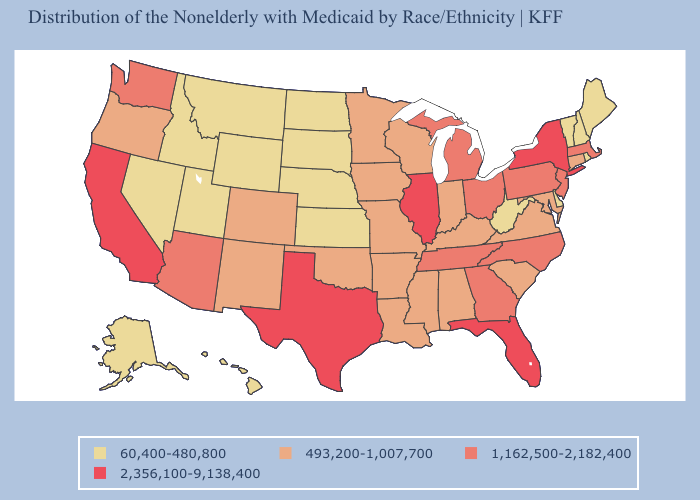Does South Dakota have the highest value in the USA?
Short answer required. No. Does Maine have the highest value in the USA?
Keep it brief. No. What is the value of Texas?
Keep it brief. 2,356,100-9,138,400. What is the value of Nevada?
Write a very short answer. 60,400-480,800. What is the lowest value in states that border Maine?
Keep it brief. 60,400-480,800. Name the states that have a value in the range 493,200-1,007,700?
Concise answer only. Alabama, Arkansas, Colorado, Connecticut, Indiana, Iowa, Kentucky, Louisiana, Maryland, Minnesota, Mississippi, Missouri, New Mexico, Oklahoma, Oregon, South Carolina, Virginia, Wisconsin. What is the lowest value in the South?
Quick response, please. 60,400-480,800. Among the states that border South Dakota , which have the lowest value?
Quick response, please. Montana, Nebraska, North Dakota, Wyoming. Does Utah have a higher value than Iowa?
Answer briefly. No. Does California have the highest value in the USA?
Give a very brief answer. Yes. What is the value of Minnesota?
Quick response, please. 493,200-1,007,700. Name the states that have a value in the range 60,400-480,800?
Concise answer only. Alaska, Delaware, Hawaii, Idaho, Kansas, Maine, Montana, Nebraska, Nevada, New Hampshire, North Dakota, Rhode Island, South Dakota, Utah, Vermont, West Virginia, Wyoming. Name the states that have a value in the range 1,162,500-2,182,400?
Give a very brief answer. Arizona, Georgia, Massachusetts, Michigan, New Jersey, North Carolina, Ohio, Pennsylvania, Tennessee, Washington. Among the states that border Michigan , does Wisconsin have the highest value?
Keep it brief. No. What is the highest value in the USA?
Concise answer only. 2,356,100-9,138,400. 